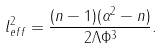<formula> <loc_0><loc_0><loc_500><loc_500>l _ { e f f } ^ { 2 } = \frac { ( n - 1 ) ( \alpha ^ { 2 } - n ) } { 2 \Lambda \Phi ^ { 3 } } .</formula> 